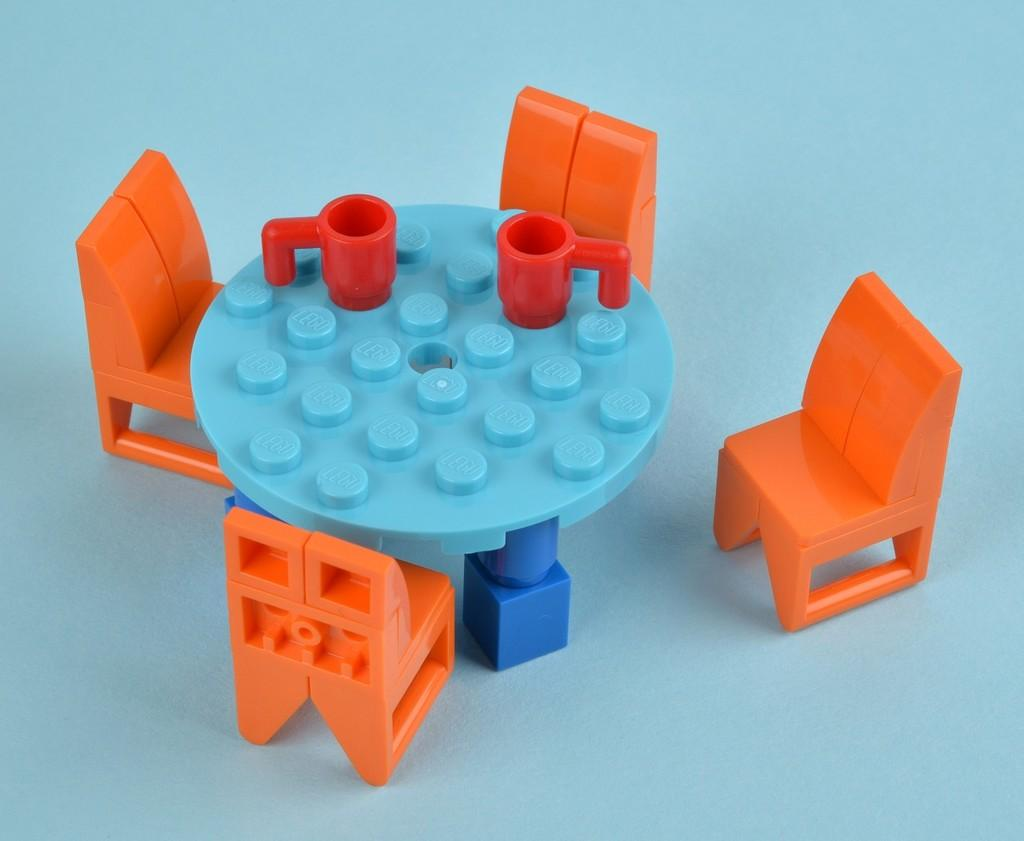What piece of furniture is present in the image? There is a table in the image. What objects are placed on the table? There are two cups on the table. How many chairs are positioned around the table? There are four chairs surrounding the table. What type of tax is being discussed in the image? There is no discussion of tax in the image; it features a table with two cups and four chairs surrounding it. 